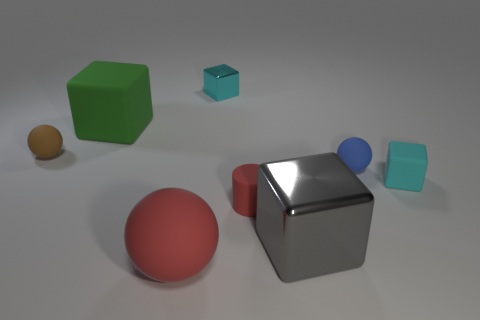Add 1 large red cylinders. How many objects exist? 9 Subtract all cylinders. How many objects are left? 7 Subtract all large green rubber blocks. Subtract all large brown matte cylinders. How many objects are left? 7 Add 8 big gray objects. How many big gray objects are left? 9 Add 5 big yellow rubber balls. How many big yellow rubber balls exist? 5 Subtract 0 yellow spheres. How many objects are left? 8 